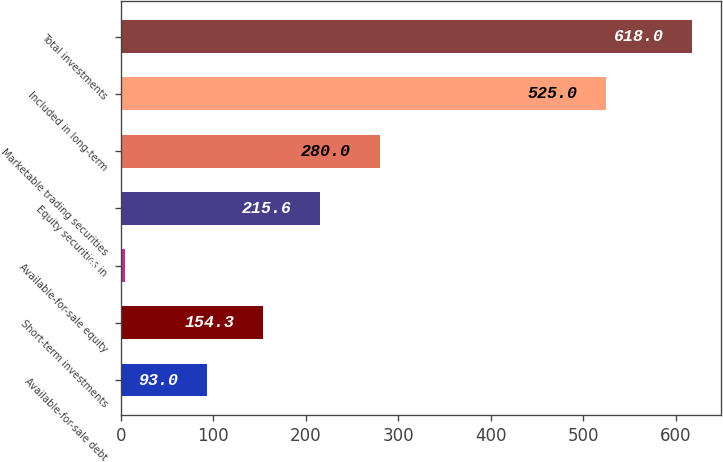Convert chart to OTSL. <chart><loc_0><loc_0><loc_500><loc_500><bar_chart><fcel>Available-for-sale debt<fcel>Short-term investments<fcel>Available-for-sale equity<fcel>Equity securities in<fcel>Marketable trading securities<fcel>Included in long-term<fcel>Total investments<nl><fcel>93<fcel>154.3<fcel>5<fcel>215.6<fcel>280<fcel>525<fcel>618<nl></chart> 